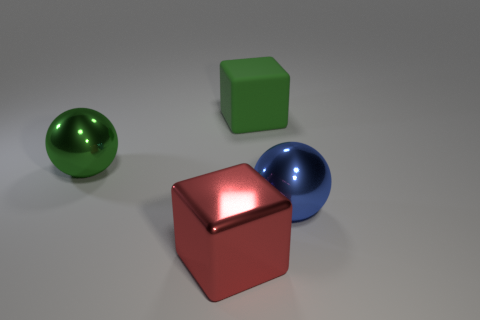Add 1 tiny red matte things. How many objects exist? 5 Add 3 green metal balls. How many green metal balls are left? 4 Add 4 large rubber things. How many large rubber things exist? 5 Subtract 0 red spheres. How many objects are left? 4 Subtract all large shiny cubes. Subtract all large spheres. How many objects are left? 1 